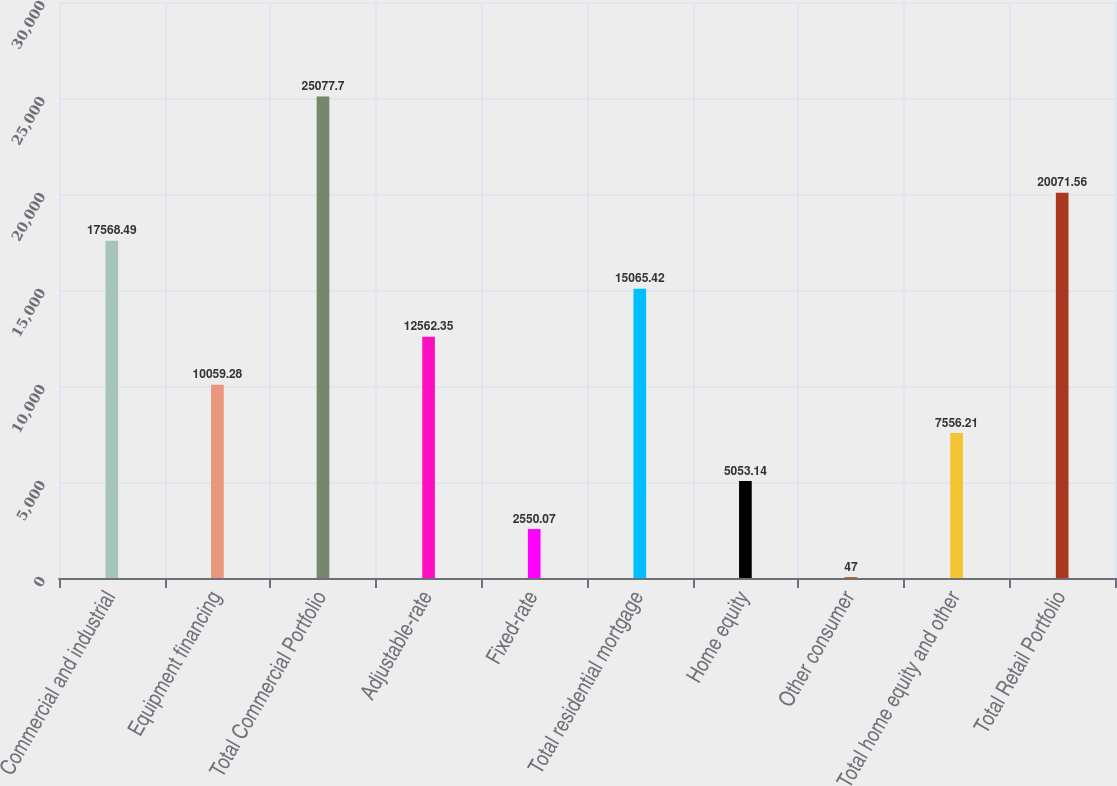<chart> <loc_0><loc_0><loc_500><loc_500><bar_chart><fcel>Commercial and industrial<fcel>Equipment financing<fcel>Total Commercial Portfolio<fcel>Adjustable-rate<fcel>Fixed-rate<fcel>Total residential mortgage<fcel>Home equity<fcel>Other consumer<fcel>Total home equity and other<fcel>Total Retail Portfolio<nl><fcel>17568.5<fcel>10059.3<fcel>25077.7<fcel>12562.4<fcel>2550.07<fcel>15065.4<fcel>5053.14<fcel>47<fcel>7556.21<fcel>20071.6<nl></chart> 